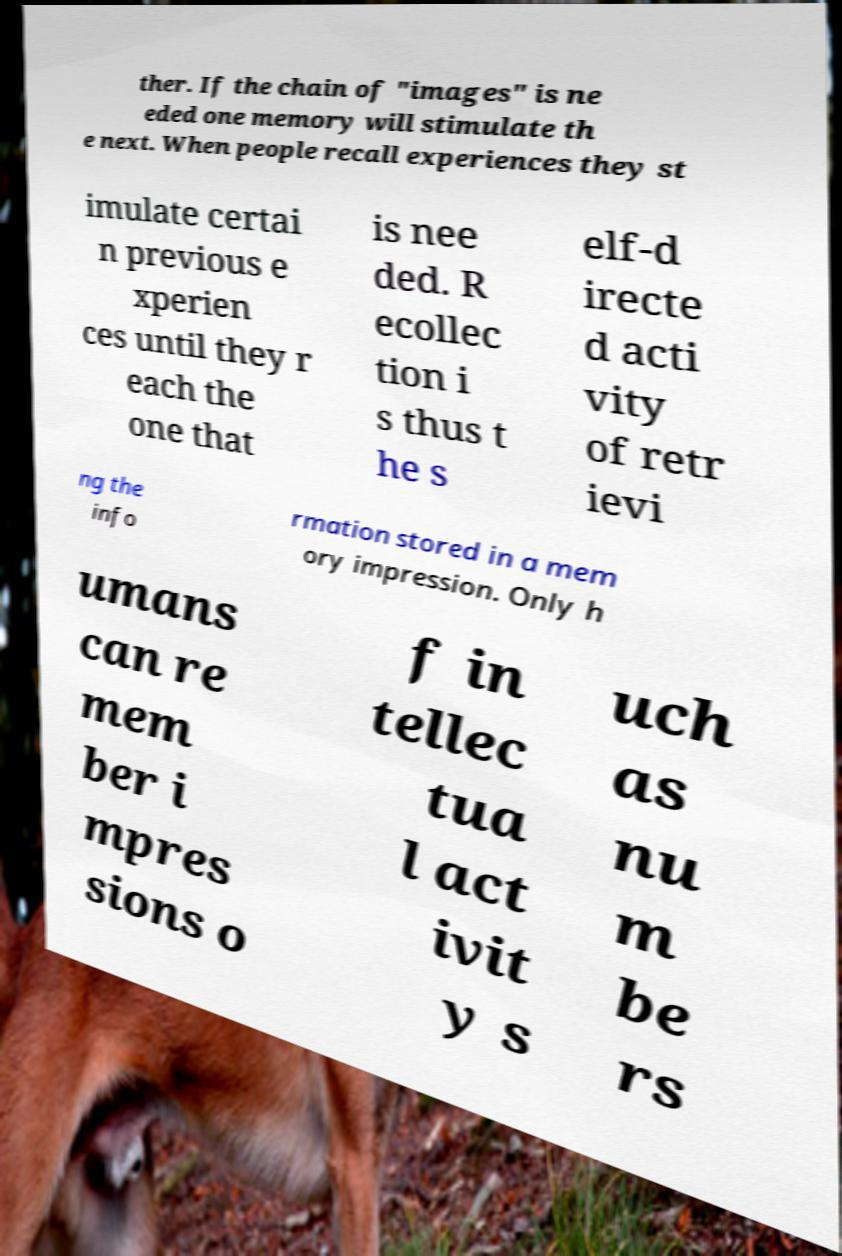Can you read and provide the text displayed in the image?This photo seems to have some interesting text. Can you extract and type it out for me? ther. If the chain of "images" is ne eded one memory will stimulate th e next. When people recall experiences they st imulate certai n previous e xperien ces until they r each the one that is nee ded. R ecollec tion i s thus t he s elf-d irecte d acti vity of retr ievi ng the info rmation stored in a mem ory impression. Only h umans can re mem ber i mpres sions o f in tellec tua l act ivit y s uch as nu m be rs 